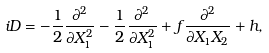Convert formula to latex. <formula><loc_0><loc_0><loc_500><loc_500>i D = - \frac { 1 } { 2 } \frac { \partial ^ { 2 } } { \partial X _ { 1 } ^ { 2 } } - \frac { 1 } { 2 } \frac { \partial ^ { 2 } } { \partial X _ { 1 } ^ { 2 } } + f \frac { \partial ^ { 2 } } { \partial X _ { 1 } X _ { 2 } } + h ,</formula> 